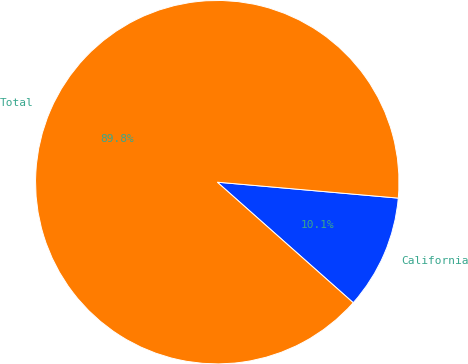<chart> <loc_0><loc_0><loc_500><loc_500><pie_chart><fcel>California<fcel>Total<nl><fcel>10.15%<fcel>89.85%<nl></chart> 